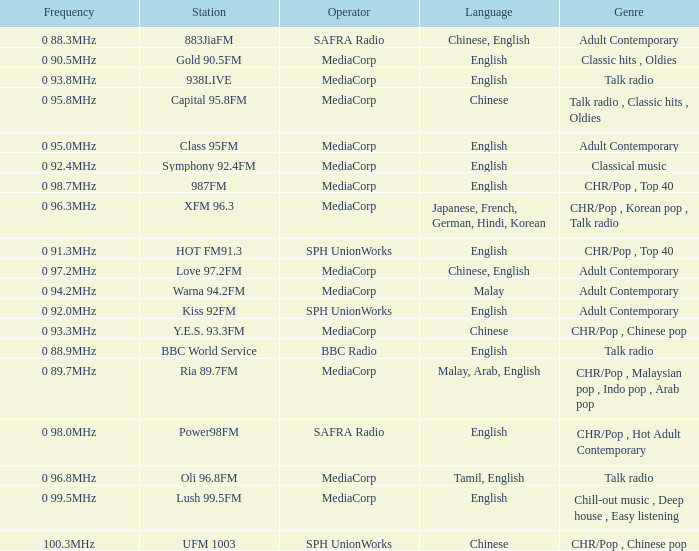What genre has a station of Class 95FM? Adult Contemporary. 